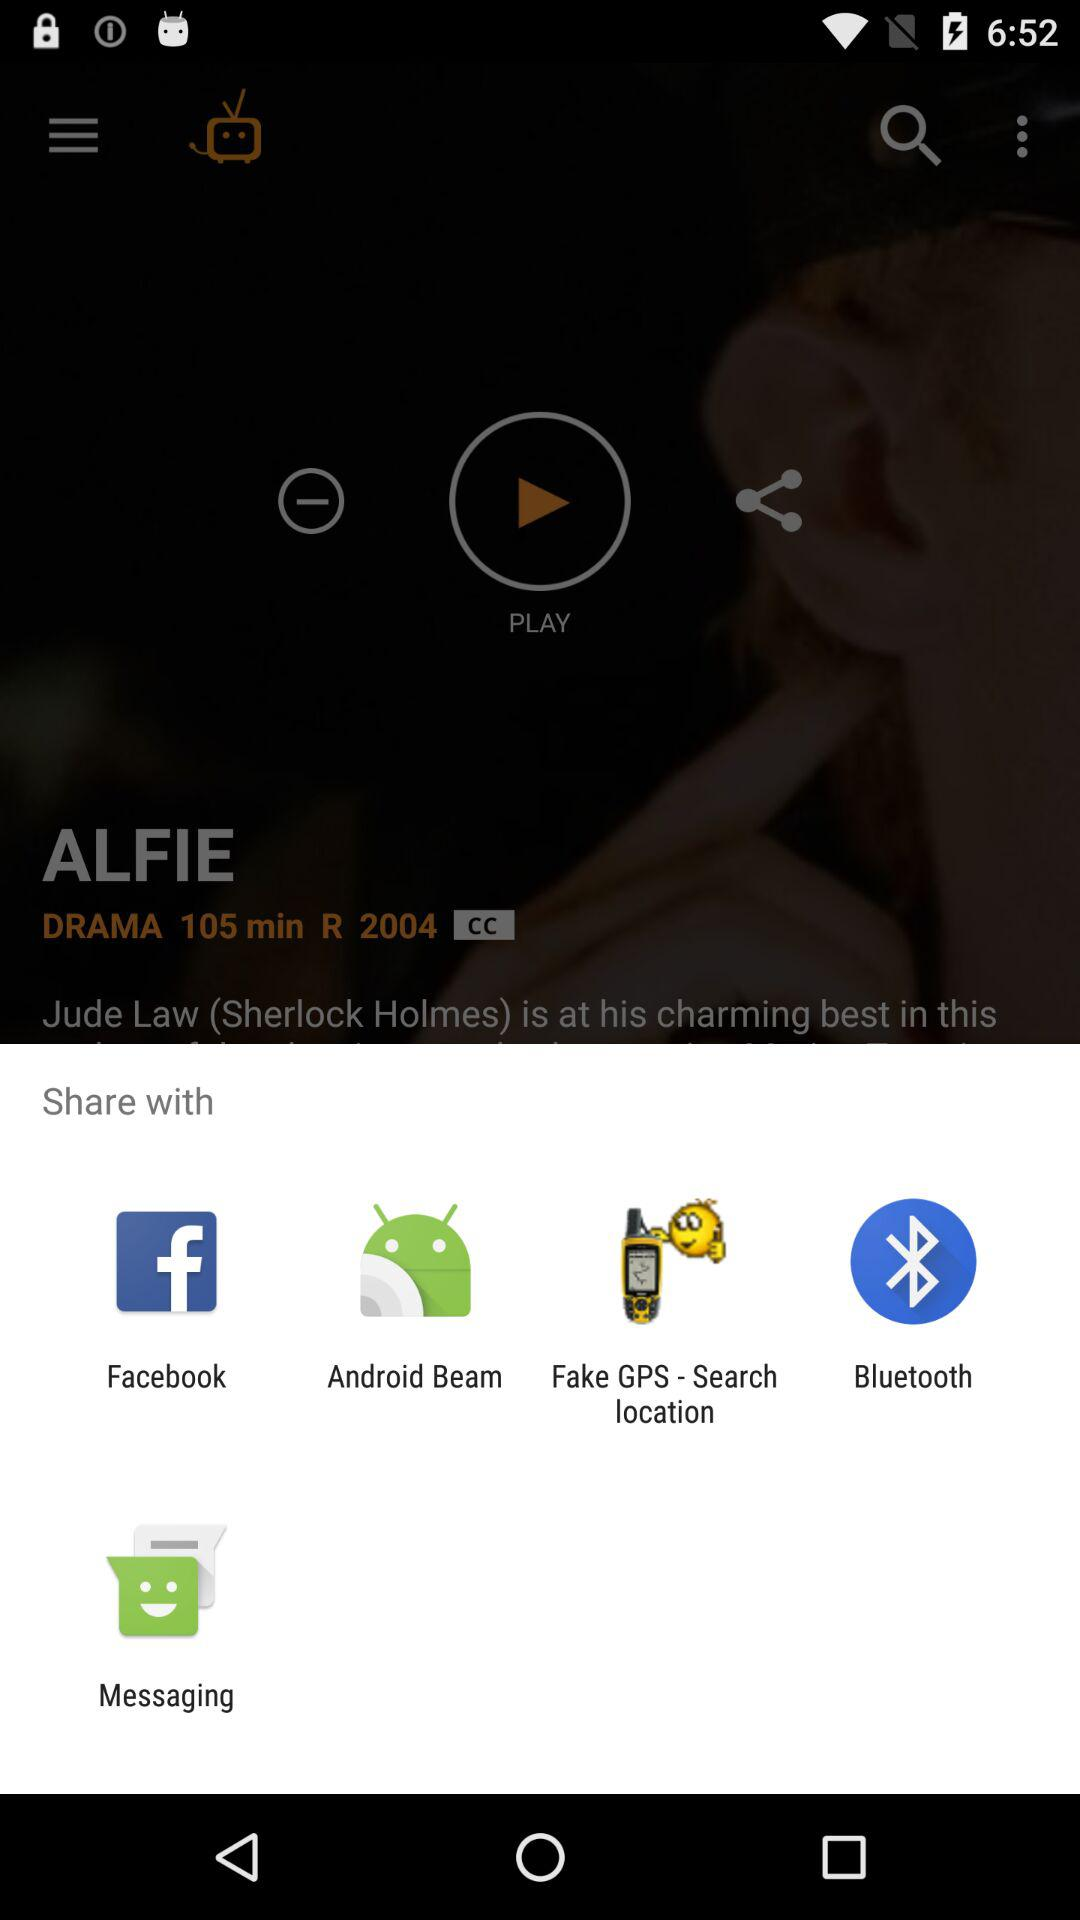How many options are available to share song? The options are "Facebook", "Android Beam", "Fake GPS-Search location", "Bluetooth" and "Messaging". 